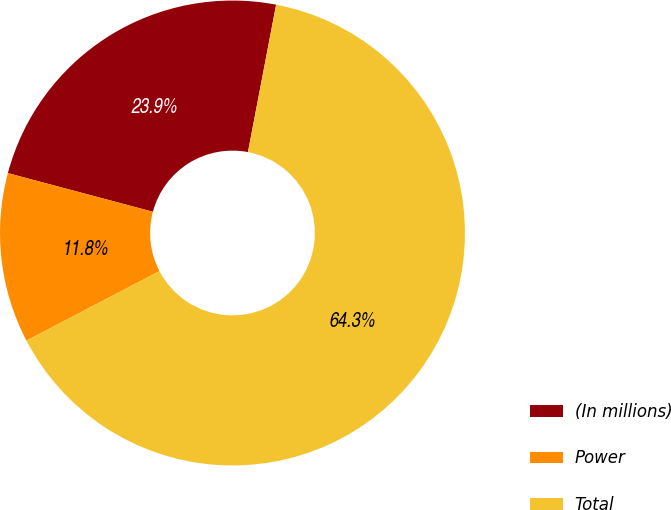Convert chart to OTSL. <chart><loc_0><loc_0><loc_500><loc_500><pie_chart><fcel>(In millions)<fcel>Power<fcel>Total<nl><fcel>23.86%<fcel>11.81%<fcel>64.33%<nl></chart> 